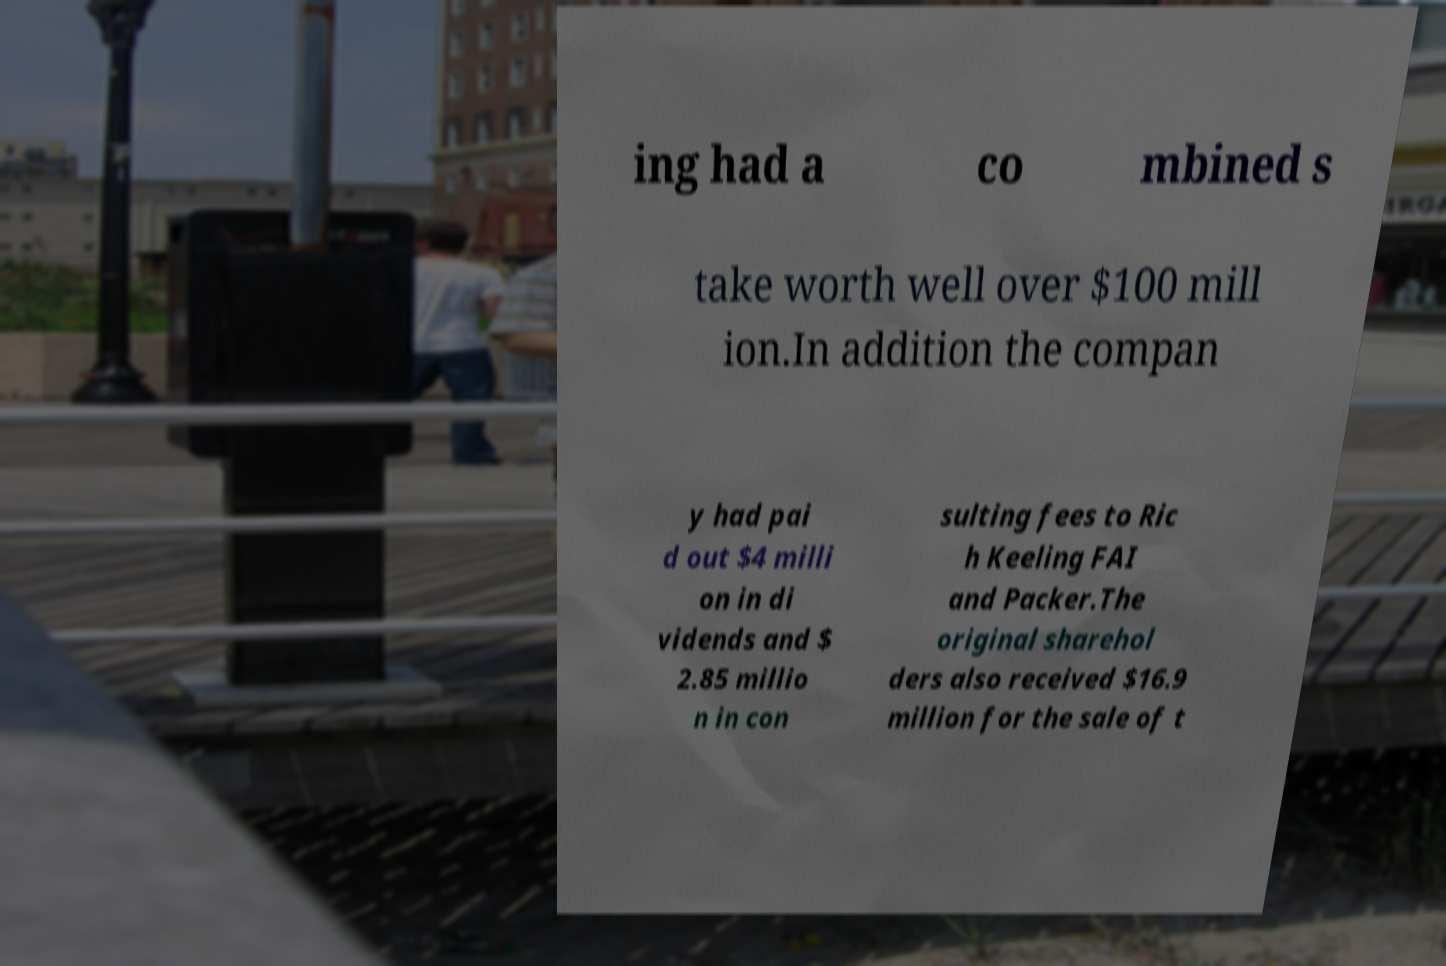There's text embedded in this image that I need extracted. Can you transcribe it verbatim? ing had a co mbined s take worth well over $100 mill ion.In addition the compan y had pai d out $4 milli on in di vidends and $ 2.85 millio n in con sulting fees to Ric h Keeling FAI and Packer.The original sharehol ders also received $16.9 million for the sale of t 